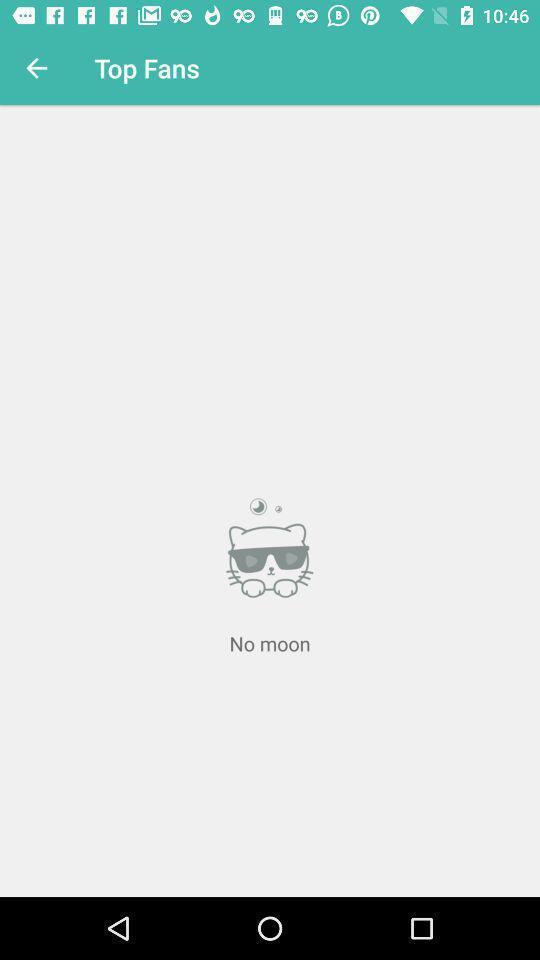Explain what's happening in this screen capture. Top fans tab in the application with empty status. 